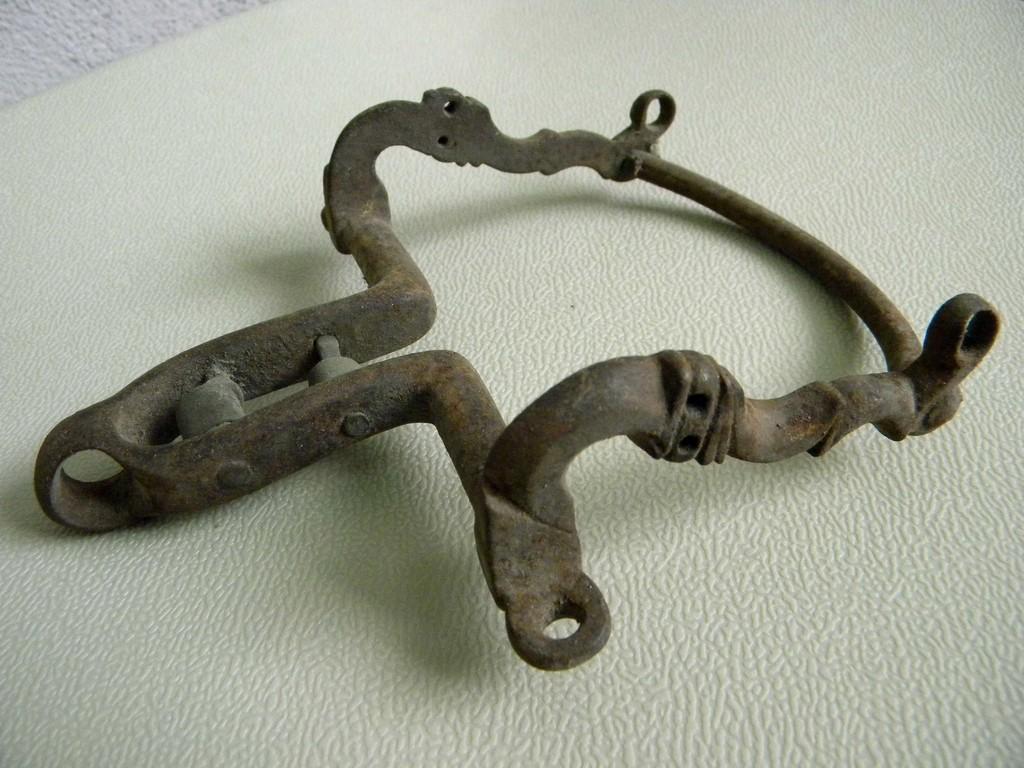How would you summarize this image in a sentence or two? In this picture, we see a metal object which looks like a handle or it might be an antique. In the background, it is white in color. It might be a table. 